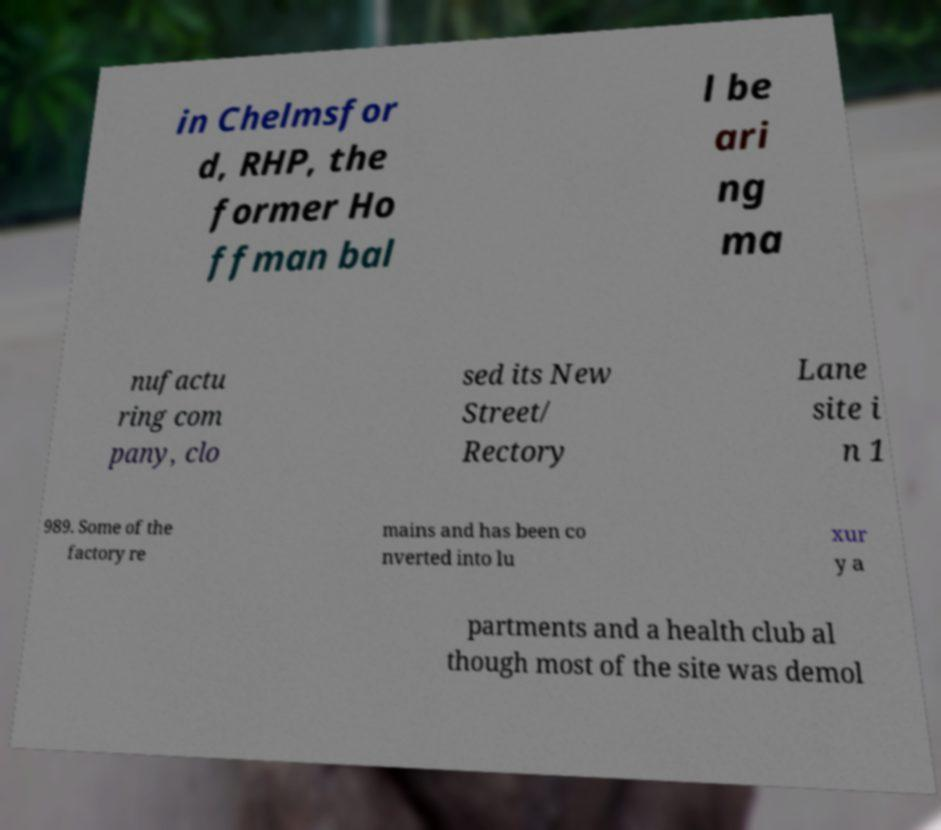Can you accurately transcribe the text from the provided image for me? in Chelmsfor d, RHP, the former Ho ffman bal l be ari ng ma nufactu ring com pany, clo sed its New Street/ Rectory Lane site i n 1 989. Some of the factory re mains and has been co nverted into lu xur y a partments and a health club al though most of the site was demol 